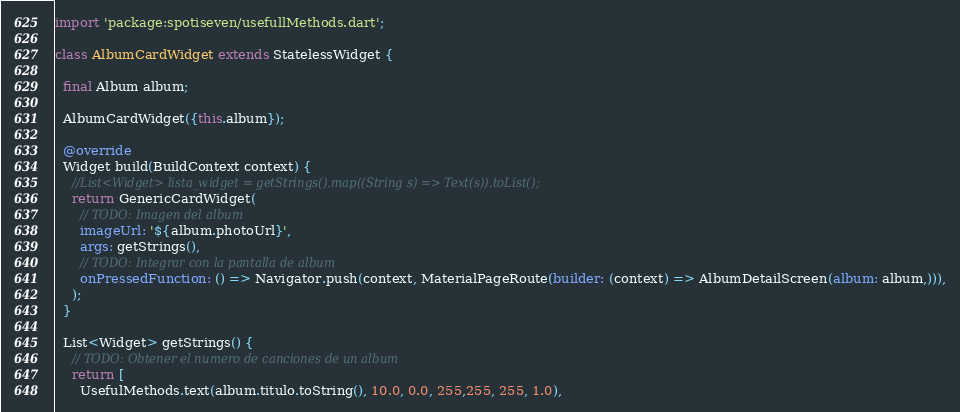Convert code to text. <code><loc_0><loc_0><loc_500><loc_500><_Dart_>import 'package:spotiseven/usefullMethods.dart';

class AlbumCardWidget extends StatelessWidget {

  final Album album;

  AlbumCardWidget({this.album});

  @override
  Widget build(BuildContext context) {
    //List<Widget> lista_widget = getStrings().map((String s) => Text(s)).toList();
    return GenericCardWidget(
      // TODO: Imagen del album
      imageUrl: '${album.photoUrl}',
      args: getStrings(),
      // TODO: Integrar con la pantalla de album
      onPressedFunction: () => Navigator.push(context, MaterialPageRoute(builder: (context) => AlbumDetailScreen(album: album,))),
    );
  }

  List<Widget> getStrings() {
    // TODO: Obtener el numero de canciones de un album
    return [
      UsefulMethods.text(album.titulo.toString(), 10.0, 0.0, 255,255, 255, 1.0),</code> 